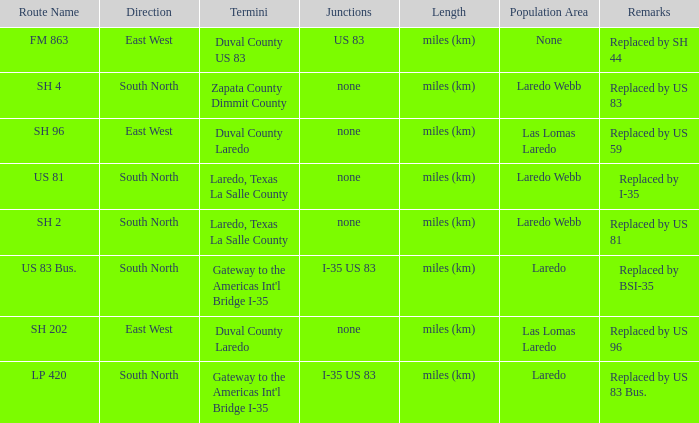How many junctions have "replaced by bsi-35" listed in their remarks section? 1.0. 